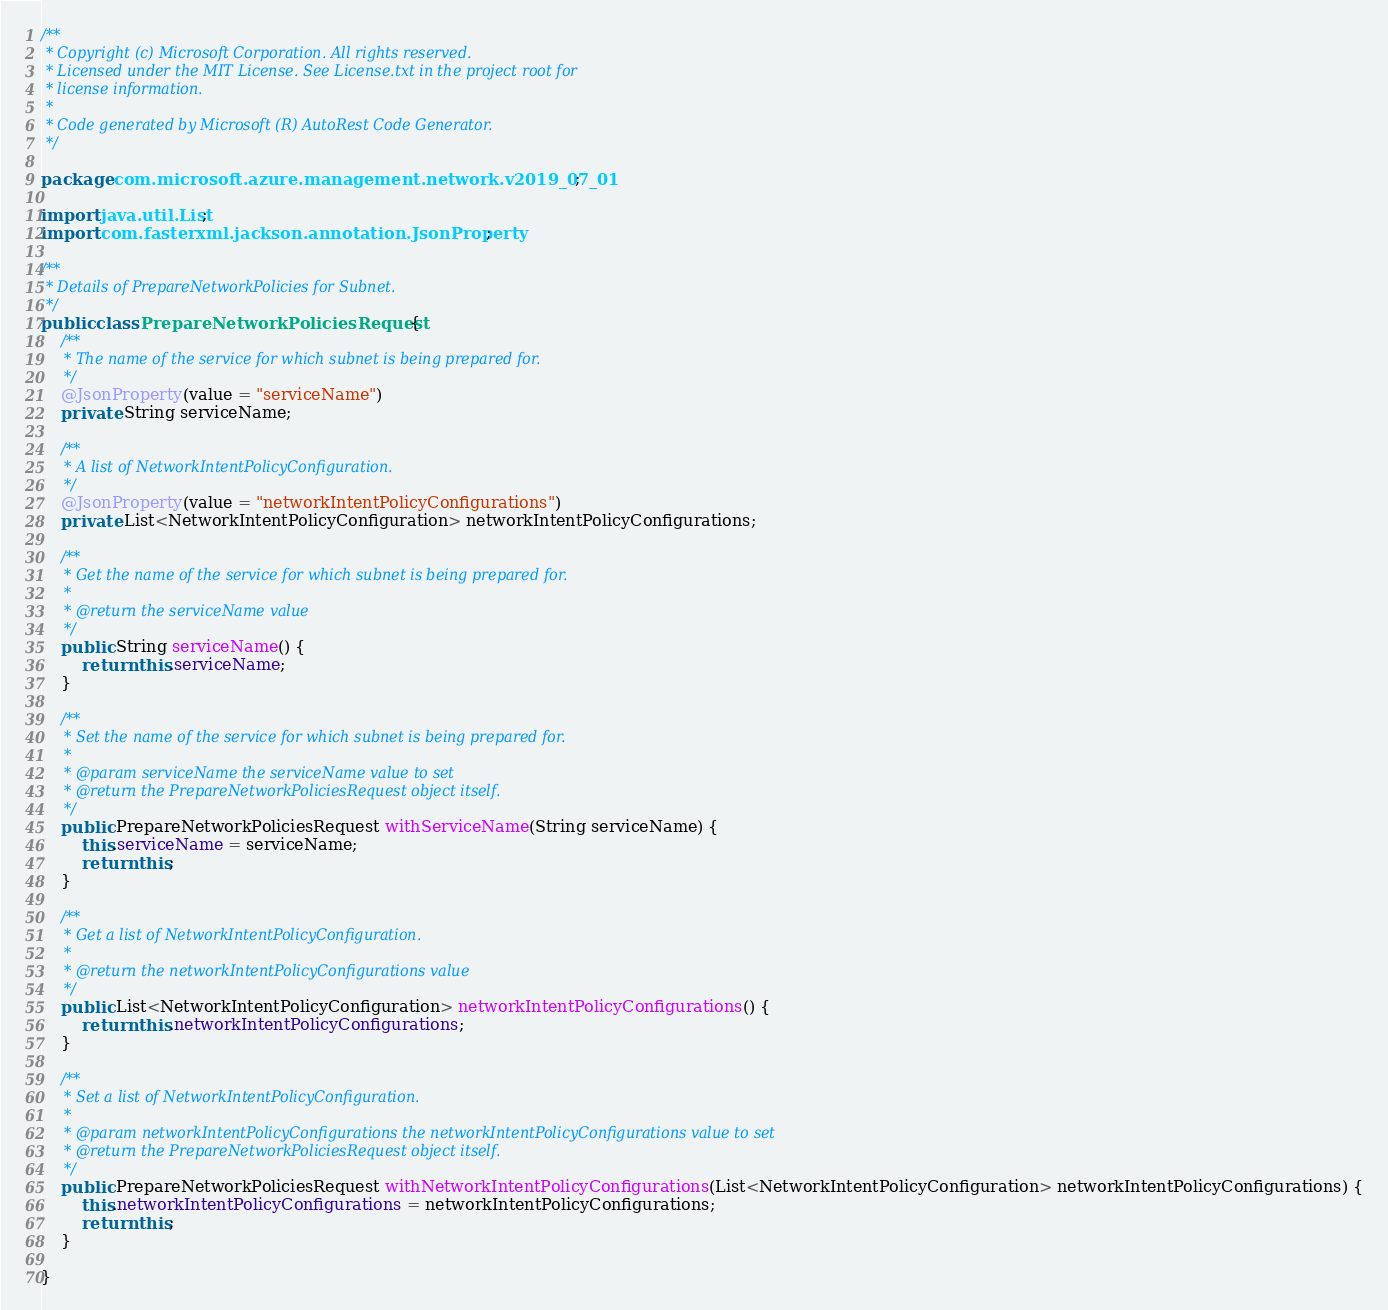<code> <loc_0><loc_0><loc_500><loc_500><_Java_>/**
 * Copyright (c) Microsoft Corporation. All rights reserved.
 * Licensed under the MIT License. See License.txt in the project root for
 * license information.
 *
 * Code generated by Microsoft (R) AutoRest Code Generator.
 */

package com.microsoft.azure.management.network.v2019_07_01;

import java.util.List;
import com.fasterxml.jackson.annotation.JsonProperty;

/**
 * Details of PrepareNetworkPolicies for Subnet.
 */
public class PrepareNetworkPoliciesRequest {
    /**
     * The name of the service for which subnet is being prepared for.
     */
    @JsonProperty(value = "serviceName")
    private String serviceName;

    /**
     * A list of NetworkIntentPolicyConfiguration.
     */
    @JsonProperty(value = "networkIntentPolicyConfigurations")
    private List<NetworkIntentPolicyConfiguration> networkIntentPolicyConfigurations;

    /**
     * Get the name of the service for which subnet is being prepared for.
     *
     * @return the serviceName value
     */
    public String serviceName() {
        return this.serviceName;
    }

    /**
     * Set the name of the service for which subnet is being prepared for.
     *
     * @param serviceName the serviceName value to set
     * @return the PrepareNetworkPoliciesRequest object itself.
     */
    public PrepareNetworkPoliciesRequest withServiceName(String serviceName) {
        this.serviceName = serviceName;
        return this;
    }

    /**
     * Get a list of NetworkIntentPolicyConfiguration.
     *
     * @return the networkIntentPolicyConfigurations value
     */
    public List<NetworkIntentPolicyConfiguration> networkIntentPolicyConfigurations() {
        return this.networkIntentPolicyConfigurations;
    }

    /**
     * Set a list of NetworkIntentPolicyConfiguration.
     *
     * @param networkIntentPolicyConfigurations the networkIntentPolicyConfigurations value to set
     * @return the PrepareNetworkPoliciesRequest object itself.
     */
    public PrepareNetworkPoliciesRequest withNetworkIntentPolicyConfigurations(List<NetworkIntentPolicyConfiguration> networkIntentPolicyConfigurations) {
        this.networkIntentPolicyConfigurations = networkIntentPolicyConfigurations;
        return this;
    }

}
</code> 